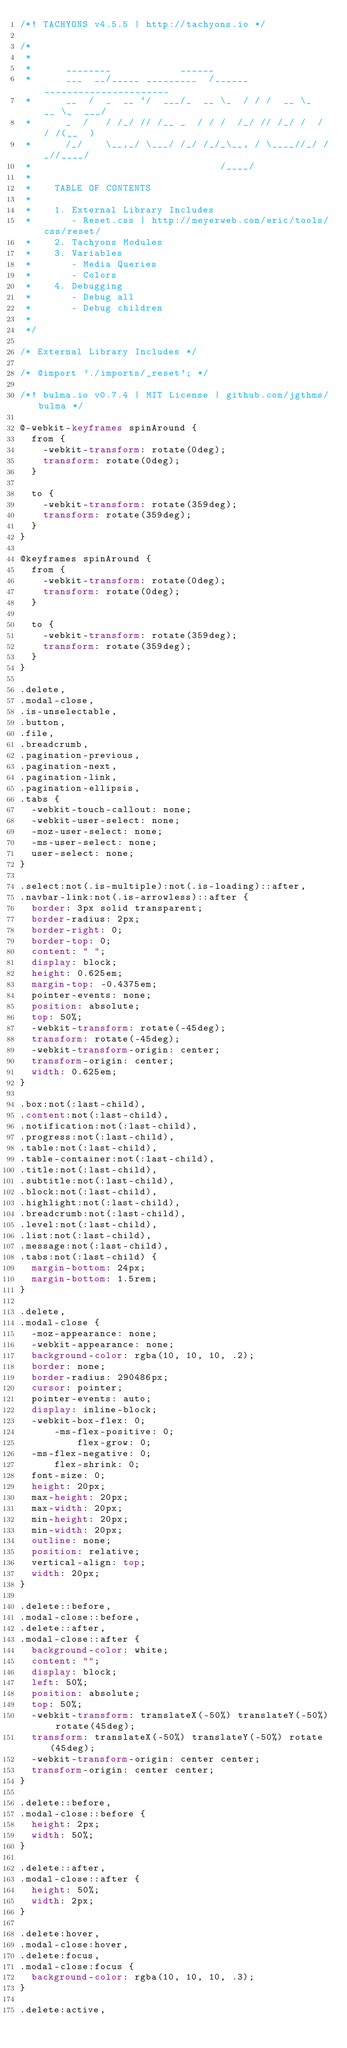Convert code to text. <code><loc_0><loc_0><loc_500><loc_500><_CSS_>/*! TACHYONS v4.5.5 | http://tachyons.io */

/*
 *
 *      ________            ______
 *      ___  __/_____ _________  /______  ______________________
 *      __  /  _  __ `/  ___/_  __ \_  / / /  __ \_  __ \_  ___/
 *      _  /   / /_/ // /__ _  / / /  /_/ // /_/ /  / / /(__  )
 *      /_/    \__,_/ \___/ /_/ /_/_\__, / \____//_/ /_//____/
 *                                 /____/
 *
 *    TABLE OF CONTENTS
 *
 *    1. External Library Includes
 *       - Reset.css | http://meyerweb.com/eric/tools/css/reset/
 *    2. Tachyons Modules
 *    3. Variables
 *       - Media Queries
 *       - Colors
 *    4. Debugging
 *       - Debug all
 *       - Debug children
 *
 */

/* External Library Includes */

/* @import './imports/_reset'; */

/*! bulma.io v0.7.4 | MIT License | github.com/jgthms/bulma */

@-webkit-keyframes spinAround {
  from {
    -webkit-transform: rotate(0deg);
    transform: rotate(0deg);
  }

  to {
    -webkit-transform: rotate(359deg);
    transform: rotate(359deg);
  }
}

@keyframes spinAround {
  from {
    -webkit-transform: rotate(0deg);
    transform: rotate(0deg);
  }

  to {
    -webkit-transform: rotate(359deg);
    transform: rotate(359deg);
  }
}

.delete,
.modal-close,
.is-unselectable,
.button,
.file,
.breadcrumb,
.pagination-previous,
.pagination-next,
.pagination-link,
.pagination-ellipsis,
.tabs {
  -webkit-touch-callout: none;
  -webkit-user-select: none;
  -moz-user-select: none;
  -ms-user-select: none;
  user-select: none;
}

.select:not(.is-multiple):not(.is-loading)::after,
.navbar-link:not(.is-arrowless)::after {
  border: 3px solid transparent;
  border-radius: 2px;
  border-right: 0;
  border-top: 0;
  content: " ";
  display: block;
  height: 0.625em;
  margin-top: -0.4375em;
  pointer-events: none;
  position: absolute;
  top: 50%;
  -webkit-transform: rotate(-45deg);
  transform: rotate(-45deg);
  -webkit-transform-origin: center;
  transform-origin: center;
  width: 0.625em;
}

.box:not(:last-child),
.content:not(:last-child),
.notification:not(:last-child),
.progress:not(:last-child),
.table:not(:last-child),
.table-container:not(:last-child),
.title:not(:last-child),
.subtitle:not(:last-child),
.block:not(:last-child),
.highlight:not(:last-child),
.breadcrumb:not(:last-child),
.level:not(:last-child),
.list:not(:last-child),
.message:not(:last-child),
.tabs:not(:last-child) {
  margin-bottom: 24px;
  margin-bottom: 1.5rem;
}

.delete,
.modal-close {
  -moz-appearance: none;
  -webkit-appearance: none;
  background-color: rgba(10, 10, 10, .2);
  border: none;
  border-radius: 290486px;
  cursor: pointer;
  pointer-events: auto;
  display: inline-block;
  -webkit-box-flex: 0;
      -ms-flex-positive: 0;
          flex-grow: 0;
  -ms-flex-negative: 0;
      flex-shrink: 0;
  font-size: 0;
  height: 20px;
  max-height: 20px;
  max-width: 20px;
  min-height: 20px;
  min-width: 20px;
  outline: none;
  position: relative;
  vertical-align: top;
  width: 20px;
}

.delete::before,
.modal-close::before,
.delete::after,
.modal-close::after {
  background-color: white;
  content: "";
  display: block;
  left: 50%;
  position: absolute;
  top: 50%;
  -webkit-transform: translateX(-50%) translateY(-50%) rotate(45deg);
  transform: translateX(-50%) translateY(-50%) rotate(45deg);
  -webkit-transform-origin: center center;
  transform-origin: center center;
}

.delete::before,
.modal-close::before {
  height: 2px;
  width: 50%;
}

.delete::after,
.modal-close::after {
  height: 50%;
  width: 2px;
}

.delete:hover,
.modal-close:hover,
.delete:focus,
.modal-close:focus {
  background-color: rgba(10, 10, 10, .3);
}

.delete:active,</code> 